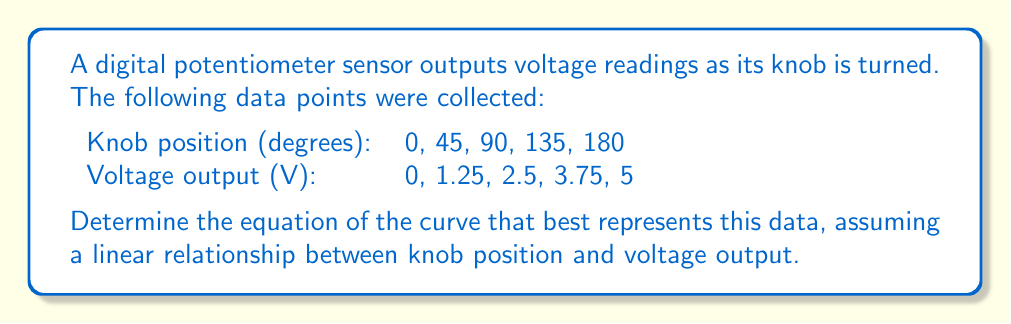What is the answer to this math problem? Let's approach this step-by-step:

1) First, we need to recognize that this appears to be a linear relationship. The equation for a linear function is:

   $y = mx + b$

   where $m$ is the slope and $b$ is the y-intercept.

2) To find the slope $m$, we can use any two points. Let's use the first and last points:

   $m = \frac{y_2 - y_1}{x_2 - x_1} = \frac{5 - 0}{180 - 0} = \frac{5}{180} = \frac{1}{36}$

3) Now that we have the slope, we can use any point to find $b$. Let's use (0, 0):

   $0 = \frac{1}{36}(0) + b$
   $b = 0$

4) Therefore, our equation is:

   $y = \frac{1}{36}x + 0$

   or simply:

   $y = \frac{1}{36}x$

5) In the context of our problem:
   
   $V = \frac{1}{36}\theta$

   Where $V$ is the voltage output and $\theta$ is the knob position in degrees.

6) To verify, let's check a middle point:
   
   When $\theta = 90°$, $V = \frac{1}{36}(90) = 2.5V$, which matches our data.
Answer: $V = \frac{1}{36}\theta$ 